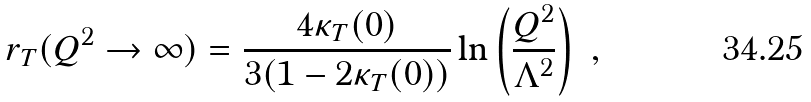Convert formula to latex. <formula><loc_0><loc_0><loc_500><loc_500>r _ { T } ( Q ^ { 2 } \to \infty ) = \frac { 4 \kappa _ { T } ( 0 ) } { 3 ( 1 - 2 \kappa _ { T } ( 0 ) ) } \ln \left ( \frac { Q ^ { 2 } } { \Lambda ^ { 2 } } \right ) \ ,</formula> 